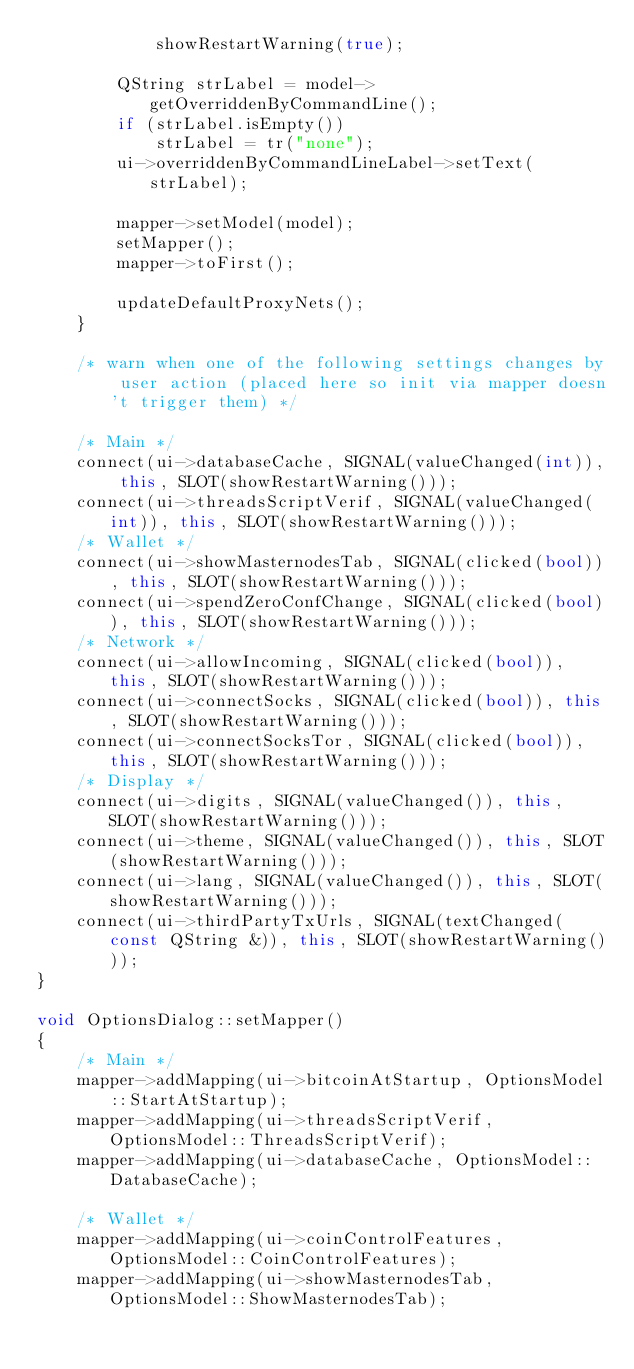Convert code to text. <code><loc_0><loc_0><loc_500><loc_500><_C++_>            showRestartWarning(true);

        QString strLabel = model->getOverriddenByCommandLine();
        if (strLabel.isEmpty())
            strLabel = tr("none");
        ui->overriddenByCommandLineLabel->setText(strLabel);

        mapper->setModel(model);
        setMapper();
        mapper->toFirst();

        updateDefaultProxyNets();
    }

    /* warn when one of the following settings changes by user action (placed here so init via mapper doesn't trigger them) */

    /* Main */
    connect(ui->databaseCache, SIGNAL(valueChanged(int)), this, SLOT(showRestartWarning()));
    connect(ui->threadsScriptVerif, SIGNAL(valueChanged(int)), this, SLOT(showRestartWarning()));
    /* Wallet */
    connect(ui->showMasternodesTab, SIGNAL(clicked(bool)), this, SLOT(showRestartWarning()));
    connect(ui->spendZeroConfChange, SIGNAL(clicked(bool)), this, SLOT(showRestartWarning()));
    /* Network */
    connect(ui->allowIncoming, SIGNAL(clicked(bool)), this, SLOT(showRestartWarning()));
    connect(ui->connectSocks, SIGNAL(clicked(bool)), this, SLOT(showRestartWarning()));
    connect(ui->connectSocksTor, SIGNAL(clicked(bool)), this, SLOT(showRestartWarning()));
    /* Display */
    connect(ui->digits, SIGNAL(valueChanged()), this, SLOT(showRestartWarning()));
    connect(ui->theme, SIGNAL(valueChanged()), this, SLOT(showRestartWarning()));
    connect(ui->lang, SIGNAL(valueChanged()), this, SLOT(showRestartWarning()));
    connect(ui->thirdPartyTxUrls, SIGNAL(textChanged(const QString &)), this, SLOT(showRestartWarning()));
}

void OptionsDialog::setMapper()
{
    /* Main */
    mapper->addMapping(ui->bitcoinAtStartup, OptionsModel::StartAtStartup);
    mapper->addMapping(ui->threadsScriptVerif, OptionsModel::ThreadsScriptVerif);
    mapper->addMapping(ui->databaseCache, OptionsModel::DatabaseCache);

    /* Wallet */
    mapper->addMapping(ui->coinControlFeatures, OptionsModel::CoinControlFeatures);
    mapper->addMapping(ui->showMasternodesTab, OptionsModel::ShowMasternodesTab);</code> 